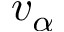<formula> <loc_0><loc_0><loc_500><loc_500>v _ { \alpha }</formula> 